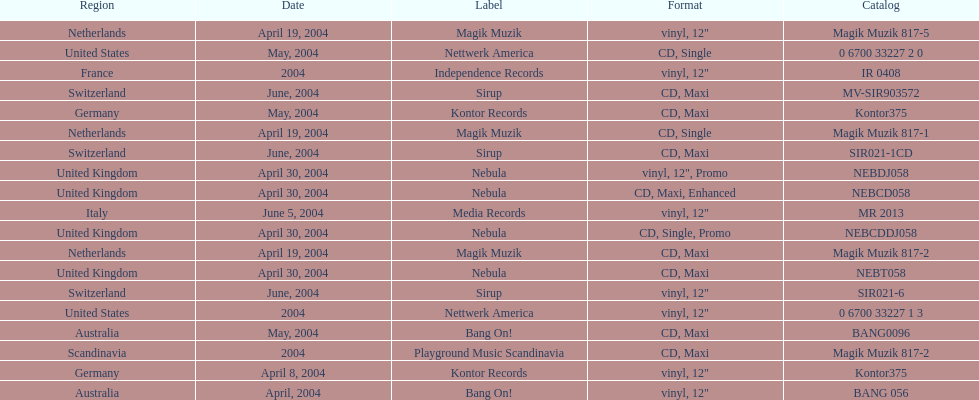What region was in the sir021-1cd catalog? Switzerland. 